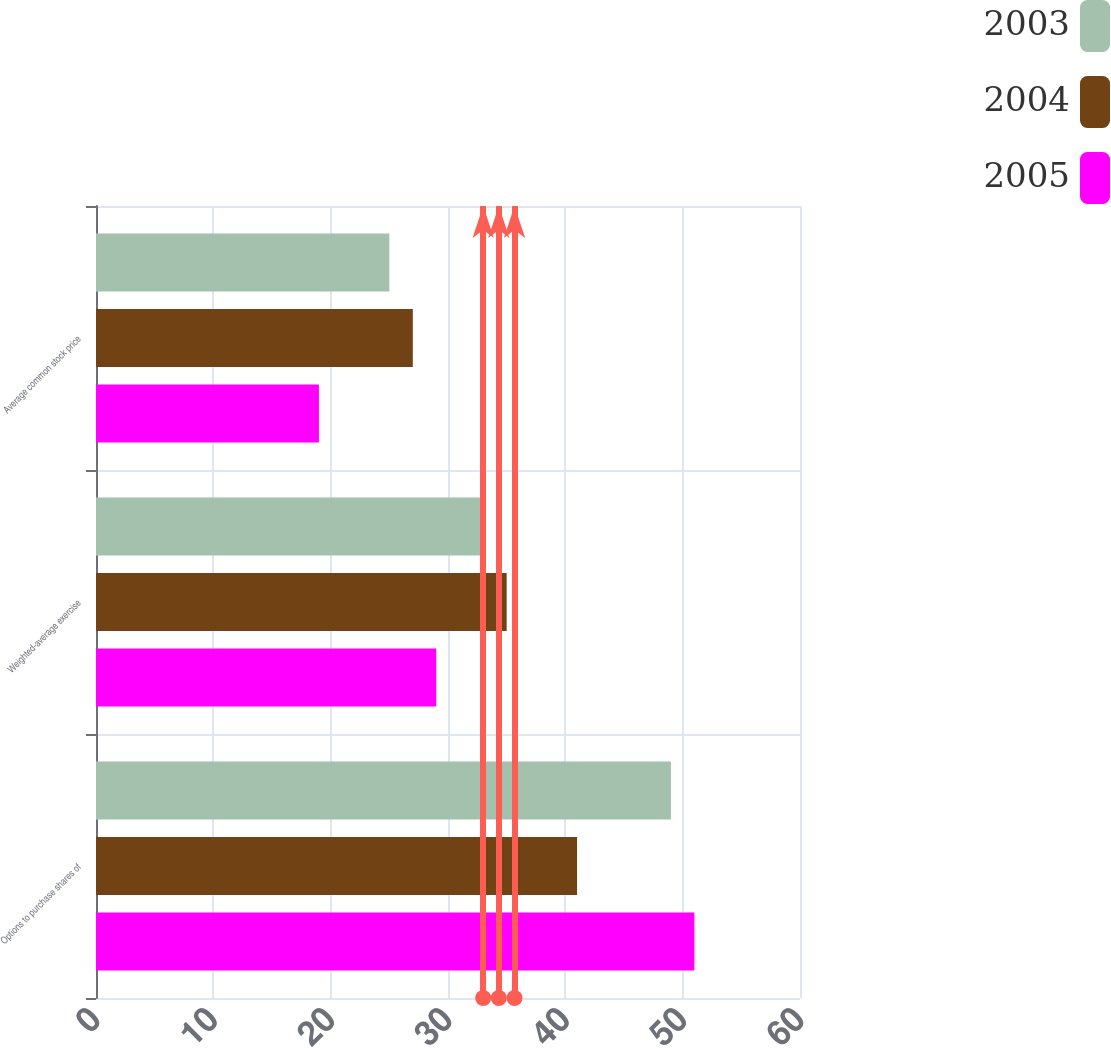<chart> <loc_0><loc_0><loc_500><loc_500><stacked_bar_chart><ecel><fcel>Options to purchase shares of<fcel>Weighted-average exercise<fcel>Average common stock price<nl><fcel>2003<fcel>49<fcel>33<fcel>25<nl><fcel>2004<fcel>41<fcel>35<fcel>27<nl><fcel>2005<fcel>51<fcel>29<fcel>19<nl></chart> 